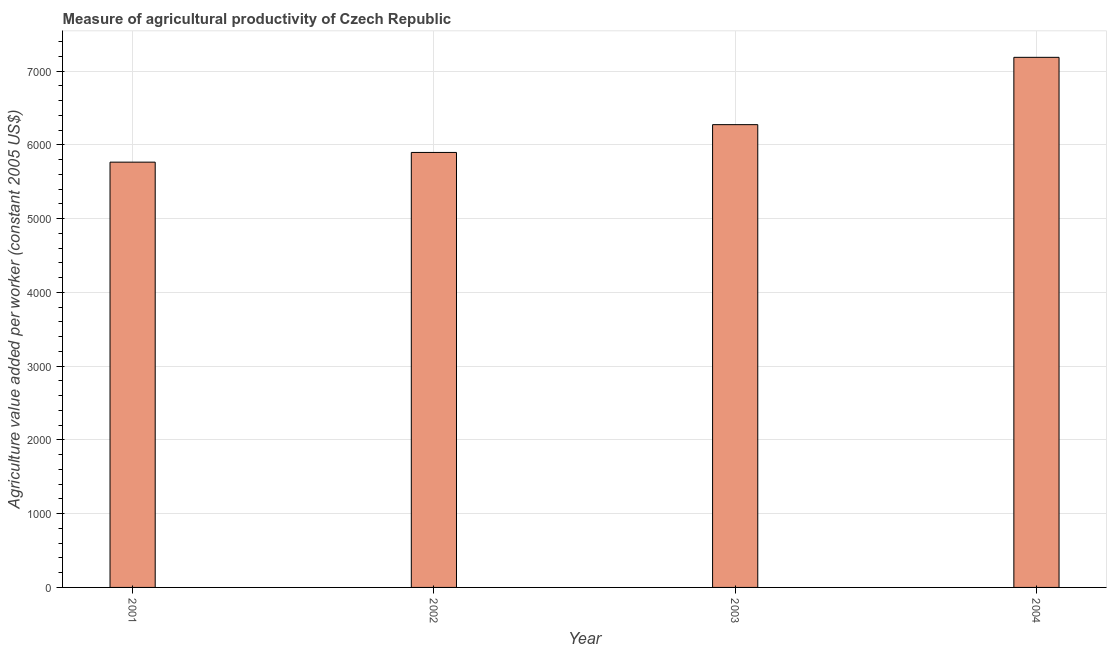Does the graph contain any zero values?
Your answer should be very brief. No. Does the graph contain grids?
Provide a short and direct response. Yes. What is the title of the graph?
Give a very brief answer. Measure of agricultural productivity of Czech Republic. What is the label or title of the Y-axis?
Your answer should be very brief. Agriculture value added per worker (constant 2005 US$). What is the agriculture value added per worker in 2004?
Make the answer very short. 7187.79. Across all years, what is the maximum agriculture value added per worker?
Offer a very short reply. 7187.79. Across all years, what is the minimum agriculture value added per worker?
Your response must be concise. 5766.48. What is the sum of the agriculture value added per worker?
Your answer should be very brief. 2.51e+04. What is the difference between the agriculture value added per worker in 2001 and 2004?
Your answer should be compact. -1421.31. What is the average agriculture value added per worker per year?
Your answer should be very brief. 6281.84. What is the median agriculture value added per worker?
Ensure brevity in your answer.  6086.55. In how many years, is the agriculture value added per worker greater than 6600 US$?
Your answer should be very brief. 1. Do a majority of the years between 2001 and 2004 (inclusive) have agriculture value added per worker greater than 4000 US$?
Ensure brevity in your answer.  Yes. What is the ratio of the agriculture value added per worker in 2002 to that in 2004?
Offer a terse response. 0.82. What is the difference between the highest and the second highest agriculture value added per worker?
Offer a very short reply. 912.7. What is the difference between the highest and the lowest agriculture value added per worker?
Provide a short and direct response. 1421.3. In how many years, is the agriculture value added per worker greater than the average agriculture value added per worker taken over all years?
Give a very brief answer. 1. How many years are there in the graph?
Provide a short and direct response. 4. What is the Agriculture value added per worker (constant 2005 US$) in 2001?
Provide a succinct answer. 5766.48. What is the Agriculture value added per worker (constant 2005 US$) of 2002?
Your answer should be compact. 5898.01. What is the Agriculture value added per worker (constant 2005 US$) in 2003?
Your response must be concise. 6275.09. What is the Agriculture value added per worker (constant 2005 US$) in 2004?
Your response must be concise. 7187.79. What is the difference between the Agriculture value added per worker (constant 2005 US$) in 2001 and 2002?
Make the answer very short. -131.53. What is the difference between the Agriculture value added per worker (constant 2005 US$) in 2001 and 2003?
Keep it short and to the point. -508.61. What is the difference between the Agriculture value added per worker (constant 2005 US$) in 2001 and 2004?
Keep it short and to the point. -1421.3. What is the difference between the Agriculture value added per worker (constant 2005 US$) in 2002 and 2003?
Your response must be concise. -377.08. What is the difference between the Agriculture value added per worker (constant 2005 US$) in 2002 and 2004?
Provide a succinct answer. -1289.78. What is the difference between the Agriculture value added per worker (constant 2005 US$) in 2003 and 2004?
Your answer should be compact. -912.7. What is the ratio of the Agriculture value added per worker (constant 2005 US$) in 2001 to that in 2002?
Give a very brief answer. 0.98. What is the ratio of the Agriculture value added per worker (constant 2005 US$) in 2001 to that in 2003?
Offer a terse response. 0.92. What is the ratio of the Agriculture value added per worker (constant 2005 US$) in 2001 to that in 2004?
Your answer should be compact. 0.8. What is the ratio of the Agriculture value added per worker (constant 2005 US$) in 2002 to that in 2003?
Provide a short and direct response. 0.94. What is the ratio of the Agriculture value added per worker (constant 2005 US$) in 2002 to that in 2004?
Offer a very short reply. 0.82. What is the ratio of the Agriculture value added per worker (constant 2005 US$) in 2003 to that in 2004?
Offer a very short reply. 0.87. 